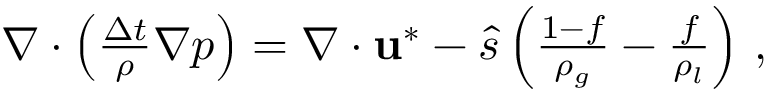Convert formula to latex. <formula><loc_0><loc_0><loc_500><loc_500>\begin{array} { r } { \nabla \cdot \left ( \frac { \Delta t } { \rho } \nabla p \right ) = \nabla \cdot u ^ { * } - \hat { s } \left ( \frac { 1 - f } { \rho _ { g } } - \frac { f } { \rho _ { l } } \right ) \, , } \end{array}</formula> 